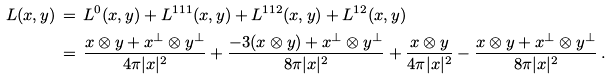<formula> <loc_0><loc_0><loc_500><loc_500>L ( x , y ) & \, = \, L ^ { 0 } ( x , y ) + L ^ { 1 1 1 } ( x , y ) + L ^ { 1 1 2 } ( x , y ) + L ^ { 1 2 } ( x , y ) \\ & \, = \, \frac { x \otimes y + x ^ { \bot } \otimes y ^ { \bot } } { 4 \pi | x | ^ { 2 } } + \frac { - 3 ( x \otimes y ) + x ^ { \bot } \otimes y ^ { \bot } } { 8 \pi | x | ^ { 2 } } + \frac { x \otimes y } { 4 \pi | x | ^ { 2 } } - \frac { x \otimes y + x ^ { \bot } \otimes y ^ { \bot } } { 8 \pi | x | ^ { 2 } } \, .</formula> 